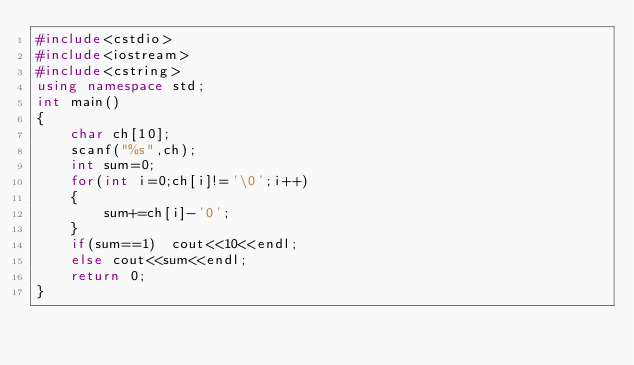Convert code to text. <code><loc_0><loc_0><loc_500><loc_500><_C++_>#include<cstdio>
#include<iostream>
#include<cstring>
using namespace std;
int main()
{
    char ch[10];
    scanf("%s",ch);
    int sum=0;
    for(int i=0;ch[i]!='\0';i++)
    {
        sum+=ch[i]-'0';
    }
    if(sum==1)  cout<<10<<endl;
    else cout<<sum<<endl;
    return 0;
}</code> 